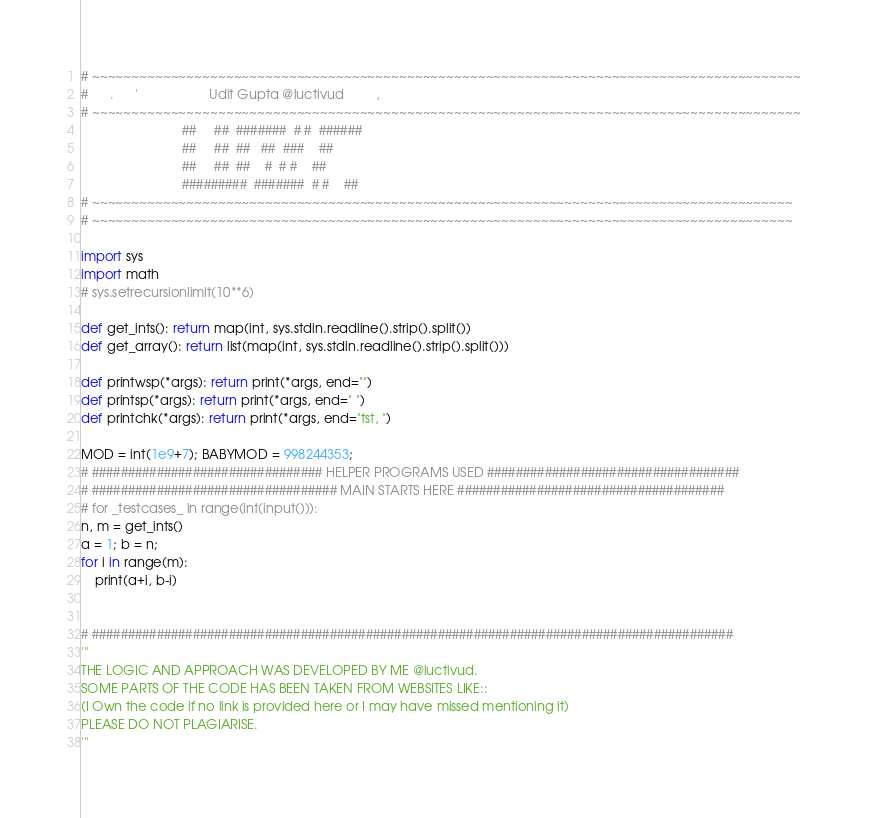<code> <loc_0><loc_0><loc_500><loc_500><_Python_># ~~~~~~~~~~~~~~~~~~~~~~~~~~~~~~~~~~~~~~~~~~~~~~~~~~~~~~~~~~~~~~~~~~~~~~~~~~~~~~~~~~~~~~~~~~ 
#      .      '                    Udit Gupta @luctivud         ,              
# ~~~~~~~~~~~~~~~~~~~~~~~~~~~~~~~~~~~~~~~~~~~~~~~~~~~~~~~~~~~~~~~~~~~~~~~~~~~~~~~~~~~~~~~~~~
                            ##     ##  #######  # #  ######
                            ##     ##  ##   ##  ###    ##
                            ##     ##  ##    #  # #    ##
                            #########  #######  # #    ##
# ~~~~~~~~~~~~~~~~~~~~~~~~~~~~~~~~~~~~~~~~~~~~~~~~~~~~~~~~~~~~~~~~~~~~~~~~~~~~~~~~~~~~~~~~~
# ~~~~~~~~~~~~~~~~~~~~~~~~~~~~~~~~~~~~~~~~~~~~~~~~~~~~~~~~~~~~~~~~~~~~~~~~~~~~~~~~~~~~~~~~~

import sys
import math
# sys.setrecursionlimit(10**6)

def get_ints(): return map(int, sys.stdin.readline().strip().split())
def get_array(): return list(map(int, sys.stdin.readline().strip().split()))

def printwsp(*args): return print(*args, end="")
def printsp(*args): return print(*args, end=" ")
def printchk(*args): return print(*args, end="tst, ")

MOD = int(1e9+7); BABYMOD = 998244353;
# ################################ HELPER PROGRAMS USED ###################################
# ################################## MAIN STARTS HERE #####################################
# for _testcases_ in range(int(input())):
n, m = get_ints()
a = 1; b = n;
for i in range(m):
    print(a+i, b-i)


# #########################################################################################
'''
THE LOGIC AND APPROACH WAS DEVELOPED BY ME @luctivud.
SOME PARTS OF THE CODE HAS BEEN TAKEN FROM WEBSITES LIKE::
(I Own the code if no link is provided here or I may have missed mentioning it)
PLEASE DO NOT PLAGIARISE.
'''</code> 